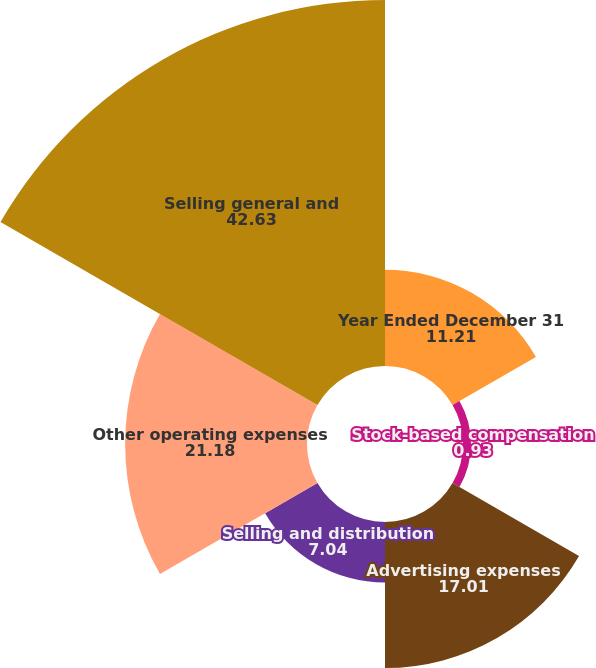Convert chart to OTSL. <chart><loc_0><loc_0><loc_500><loc_500><pie_chart><fcel>Year Ended December 31<fcel>Stock-based compensation<fcel>Advertising expenses<fcel>Selling and distribution<fcel>Other operating expenses<fcel>Selling general and<nl><fcel>11.21%<fcel>0.93%<fcel>17.01%<fcel>7.04%<fcel>21.18%<fcel>42.63%<nl></chart> 